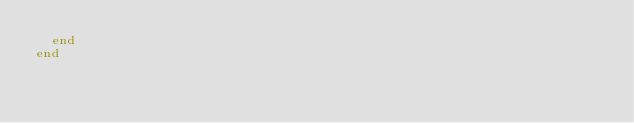<code> <loc_0><loc_0><loc_500><loc_500><_Crystal_>  end
end
</code> 